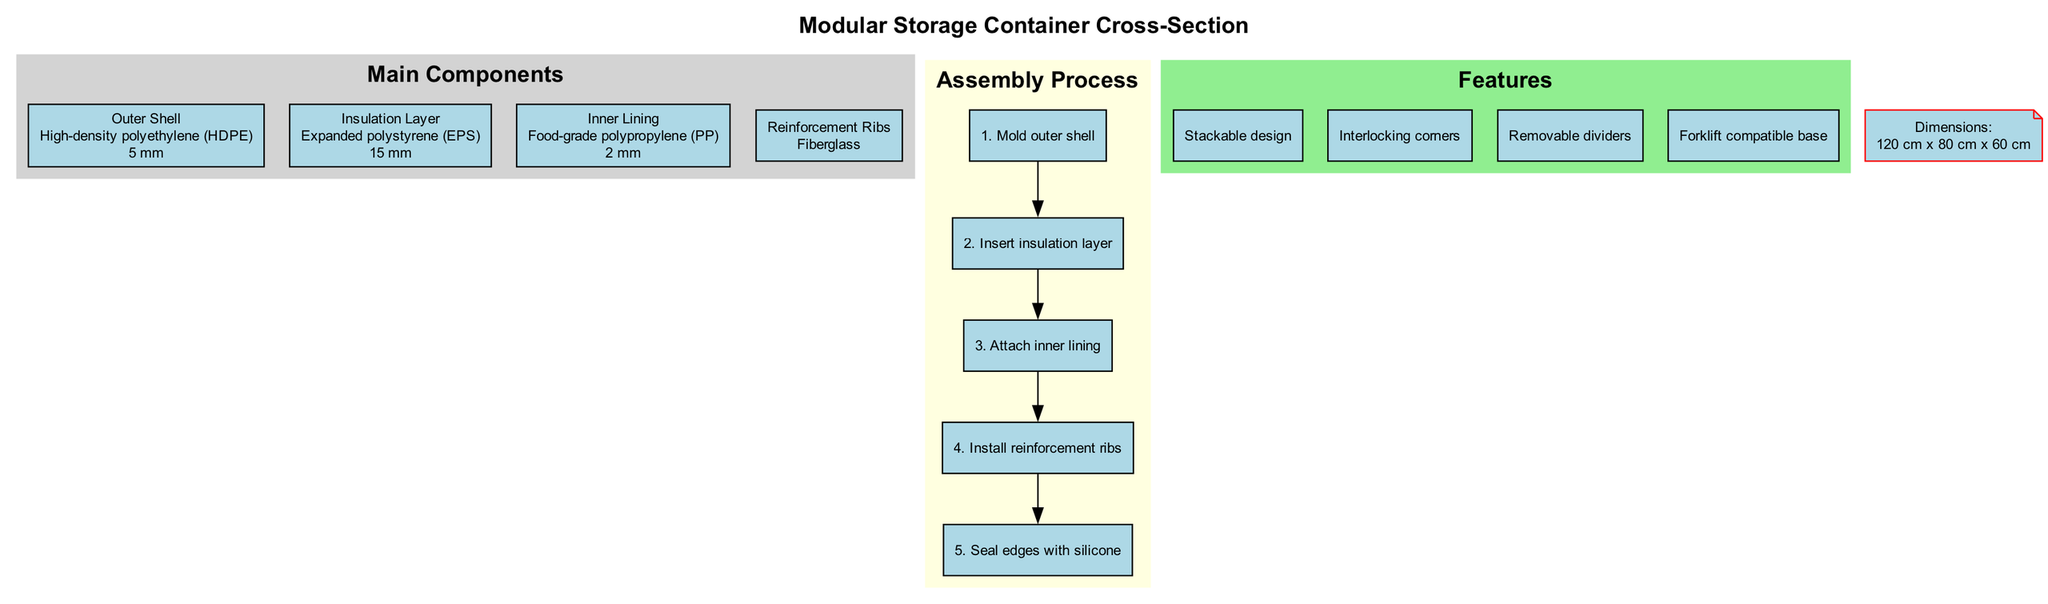What is the thickness of the outer shell? The outer shell's thickness is specifically mentioned in the diagram as "5 mm." To find this, one can refer to the node labeled "Outer Shell," where this detail is provided plainly.
Answer: 5 mm What material is used for the insulation layer? The insulation layer's material is indicated in the diagram as "Expanded polystyrene (EPS)." By looking at the node corresponding to the "Insulation Layer," this information can be easily found.
Answer: Expanded polystyrene (EPS) How many steps are in the assembly process? The assembly process section lists all individual steps involved in assembling the container. By counting these steps, which are outlined in the nodes of the assembly process subgraph, it reveals that there are a total of 5 listed steps.
Answer: 5 What is the height of the modular storage container? The height is stated within the dimensions section of the diagram, which specifies the container's height as "60 cm." This information is found under the node designated for dimensions.
Answer: 60 cm Which layer provides insulation in the container? According to the diagram, the "Insulation Layer" is explicitly labeled as the component responsible for insulation. This identification can be made by referring to its corresponding node in the main components section.
Answer: Insulation Layer How are the dimensions of the container listed? In the diagram, the dimensions are articulated as "120 cm x 80 cm x 60 cm." This format can be identified by checking the node labeled "Dimensions," which presents the measurements clearly.
Answer: 120 cm x 80 cm x 60 cm What material are the reinforcement ribs made of? The material for the reinforcement ribs is specified as "Fiberglass" in the diagram. This detail is found in the corresponding node for the "Reinforcement Ribs."
Answer: Fiberglass What is one feature of the modular storage container? The features section includes a list, and one of the mentioned features is "Stackable design." To find this, one can refer to the nodes within the features subgraph.
Answer: Stackable design What is the order of the first three steps in the assembly process? The first three steps listed in the assembly process are "Mold outer shell," "Insert insulation layer," and "Attach inner lining." This order can be determined by sequentially reviewing the nodes that represent each step.
Answer: Mold outer shell, Insert insulation layer, Attach inner lining 